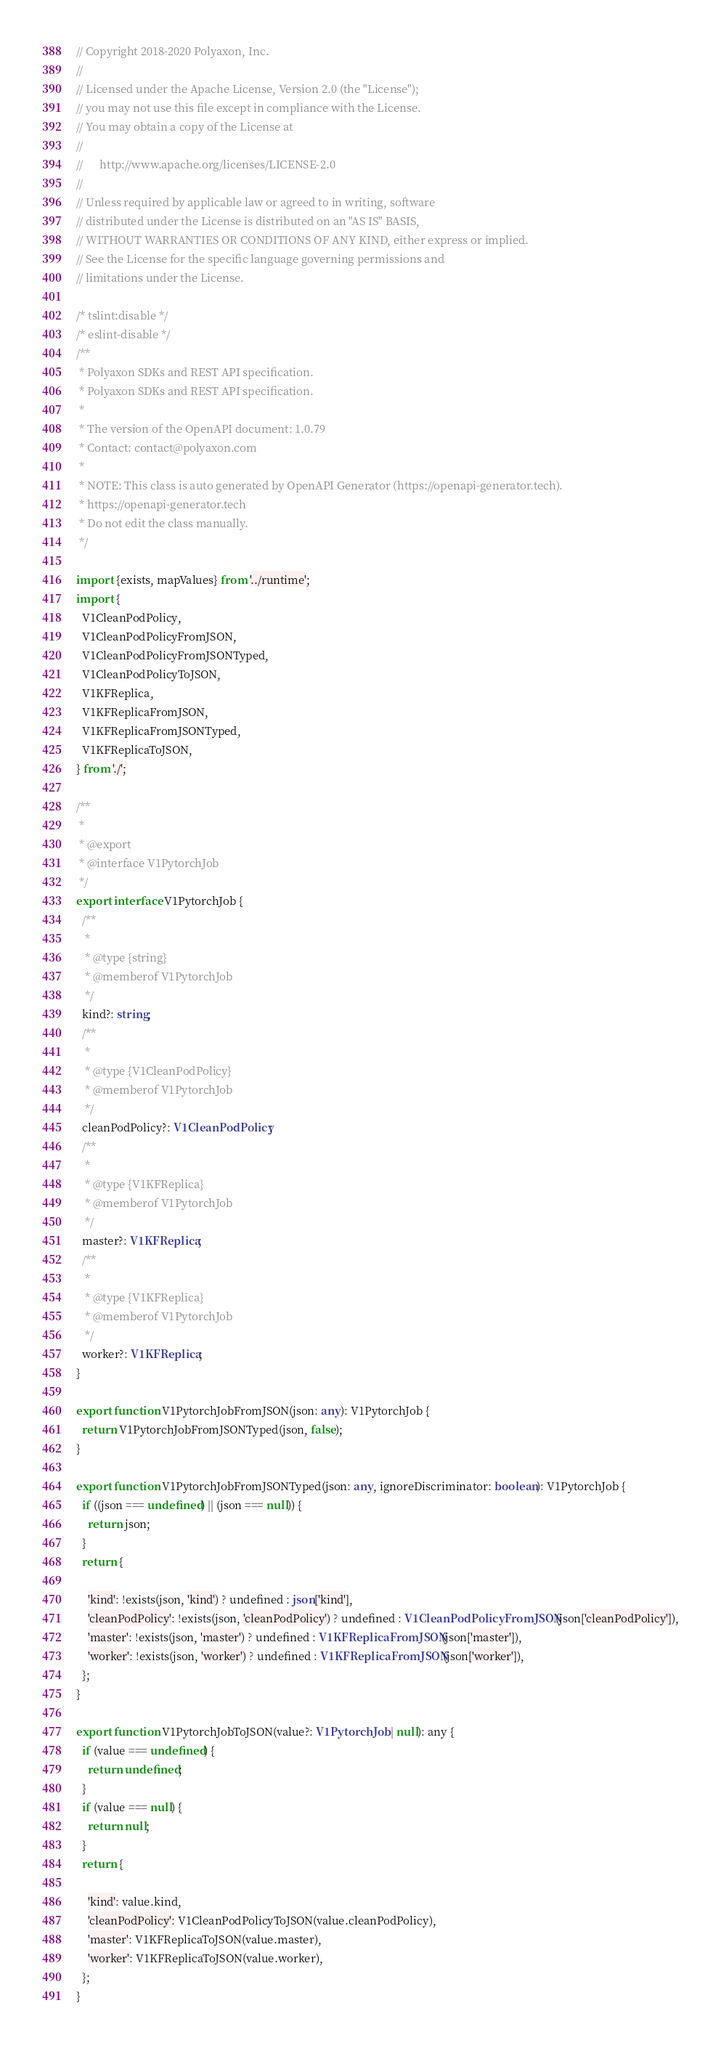<code> <loc_0><loc_0><loc_500><loc_500><_TypeScript_>// Copyright 2018-2020 Polyaxon, Inc.
//
// Licensed under the Apache License, Version 2.0 (the "License");
// you may not use this file except in compliance with the License.
// You may obtain a copy of the License at
//
//      http://www.apache.org/licenses/LICENSE-2.0
//
// Unless required by applicable law or agreed to in writing, software
// distributed under the License is distributed on an "AS IS" BASIS,
// WITHOUT WARRANTIES OR CONDITIONS OF ANY KIND, either express or implied.
// See the License for the specific language governing permissions and
// limitations under the License.

/* tslint:disable */
/* eslint-disable */
/**
 * Polyaxon SDKs and REST API specification.
 * Polyaxon SDKs and REST API specification.
 *
 * The version of the OpenAPI document: 1.0.79
 * Contact: contact@polyaxon.com
 *
 * NOTE: This class is auto generated by OpenAPI Generator (https://openapi-generator.tech).
 * https://openapi-generator.tech
 * Do not edit the class manually.
 */

import {exists, mapValues} from '../runtime';
import {
  V1CleanPodPolicy,
  V1CleanPodPolicyFromJSON,
  V1CleanPodPolicyFromJSONTyped,
  V1CleanPodPolicyToJSON,
  V1KFReplica,
  V1KFReplicaFromJSON,
  V1KFReplicaFromJSONTyped,
  V1KFReplicaToJSON,
} from './';

/**
 * 
 * @export
 * @interface V1PytorchJob
 */
export interface V1PytorchJob {
  /**
   *
   * @type {string}
   * @memberof V1PytorchJob
   */
  kind?: string;
  /**
   *
   * @type {V1CleanPodPolicy}
   * @memberof V1PytorchJob
   */
  cleanPodPolicy?: V1CleanPodPolicy;
  /**
   *
   * @type {V1KFReplica}
   * @memberof V1PytorchJob
   */
  master?: V1KFReplica;
  /**
   *
   * @type {V1KFReplica}
   * @memberof V1PytorchJob
   */
  worker?: V1KFReplica;
}

export function V1PytorchJobFromJSON(json: any): V1PytorchJob {
  return V1PytorchJobFromJSONTyped(json, false);
}

export function V1PytorchJobFromJSONTyped(json: any, ignoreDiscriminator: boolean): V1PytorchJob {
  if ((json === undefined) || (json === null)) {
    return json;
  }
  return {

    'kind': !exists(json, 'kind') ? undefined : json['kind'],
    'cleanPodPolicy': !exists(json, 'cleanPodPolicy') ? undefined : V1CleanPodPolicyFromJSON(json['cleanPodPolicy']),
    'master': !exists(json, 'master') ? undefined : V1KFReplicaFromJSON(json['master']),
    'worker': !exists(json, 'worker') ? undefined : V1KFReplicaFromJSON(json['worker']),
  };
}

export function V1PytorchJobToJSON(value?: V1PytorchJob | null): any {
  if (value === undefined) {
    return undefined;
  }
  if (value === null) {
    return null;
  }
  return {

    'kind': value.kind,
    'cleanPodPolicy': V1CleanPodPolicyToJSON(value.cleanPodPolicy),
    'master': V1KFReplicaToJSON(value.master),
    'worker': V1KFReplicaToJSON(value.worker),
  };
}


</code> 